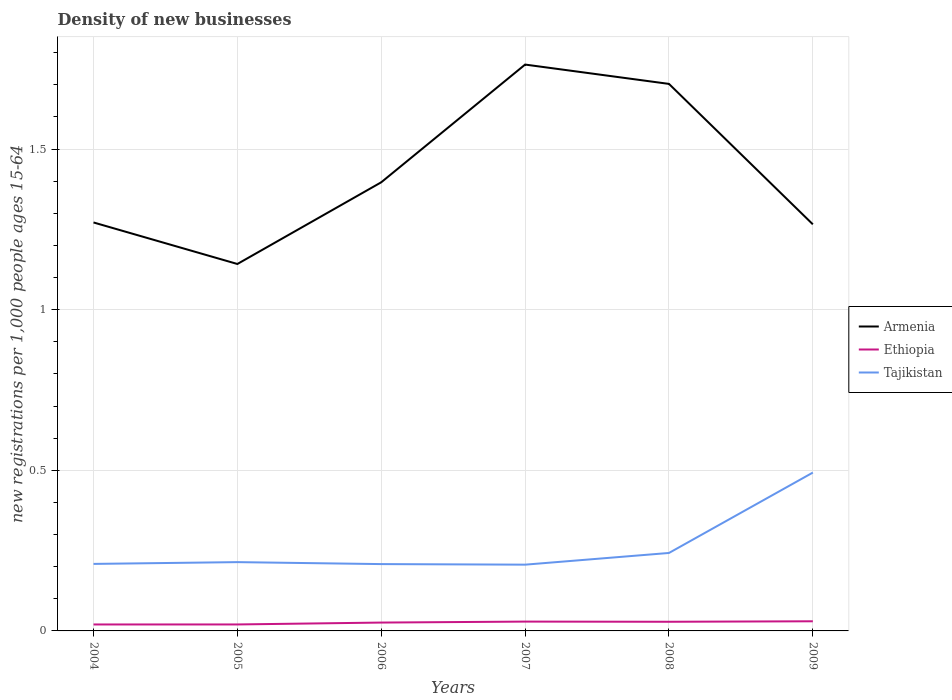How many different coloured lines are there?
Keep it short and to the point. 3. Across all years, what is the maximum number of new registrations in Armenia?
Offer a terse response. 1.14. In which year was the number of new registrations in Tajikistan maximum?
Make the answer very short. 2007. What is the total number of new registrations in Armenia in the graph?
Offer a very short reply. 0.13. What is the difference between the highest and the second highest number of new registrations in Tajikistan?
Keep it short and to the point. 0.29. What is the difference between the highest and the lowest number of new registrations in Ethiopia?
Your response must be concise. 4. How many lines are there?
Offer a terse response. 3. How many years are there in the graph?
Your answer should be compact. 6. Does the graph contain any zero values?
Provide a short and direct response. No. Where does the legend appear in the graph?
Give a very brief answer. Center right. How many legend labels are there?
Your response must be concise. 3. How are the legend labels stacked?
Give a very brief answer. Vertical. What is the title of the graph?
Give a very brief answer. Density of new businesses. What is the label or title of the Y-axis?
Your answer should be compact. New registrations per 1,0 people ages 15-64. What is the new registrations per 1,000 people ages 15-64 of Armenia in 2004?
Give a very brief answer. 1.27. What is the new registrations per 1,000 people ages 15-64 of Ethiopia in 2004?
Your answer should be very brief. 0.02. What is the new registrations per 1,000 people ages 15-64 of Tajikistan in 2004?
Offer a very short reply. 0.21. What is the new registrations per 1,000 people ages 15-64 of Armenia in 2005?
Provide a succinct answer. 1.14. What is the new registrations per 1,000 people ages 15-64 in Ethiopia in 2005?
Provide a short and direct response. 0.02. What is the new registrations per 1,000 people ages 15-64 in Tajikistan in 2005?
Offer a very short reply. 0.21. What is the new registrations per 1,000 people ages 15-64 in Armenia in 2006?
Your answer should be very brief. 1.4. What is the new registrations per 1,000 people ages 15-64 of Ethiopia in 2006?
Your answer should be compact. 0.03. What is the new registrations per 1,000 people ages 15-64 in Tajikistan in 2006?
Keep it short and to the point. 0.21. What is the new registrations per 1,000 people ages 15-64 in Armenia in 2007?
Make the answer very short. 1.76. What is the new registrations per 1,000 people ages 15-64 in Ethiopia in 2007?
Give a very brief answer. 0.03. What is the new registrations per 1,000 people ages 15-64 of Tajikistan in 2007?
Your response must be concise. 0.21. What is the new registrations per 1,000 people ages 15-64 in Armenia in 2008?
Keep it short and to the point. 1.7. What is the new registrations per 1,000 people ages 15-64 of Ethiopia in 2008?
Your answer should be very brief. 0.03. What is the new registrations per 1,000 people ages 15-64 in Tajikistan in 2008?
Ensure brevity in your answer.  0.24. What is the new registrations per 1,000 people ages 15-64 of Armenia in 2009?
Ensure brevity in your answer.  1.27. What is the new registrations per 1,000 people ages 15-64 in Tajikistan in 2009?
Provide a succinct answer. 0.49. Across all years, what is the maximum new registrations per 1,000 people ages 15-64 of Armenia?
Provide a short and direct response. 1.76. Across all years, what is the maximum new registrations per 1,000 people ages 15-64 of Ethiopia?
Keep it short and to the point. 0.03. Across all years, what is the maximum new registrations per 1,000 people ages 15-64 of Tajikistan?
Give a very brief answer. 0.49. Across all years, what is the minimum new registrations per 1,000 people ages 15-64 in Armenia?
Provide a succinct answer. 1.14. Across all years, what is the minimum new registrations per 1,000 people ages 15-64 of Ethiopia?
Ensure brevity in your answer.  0.02. Across all years, what is the minimum new registrations per 1,000 people ages 15-64 of Tajikistan?
Ensure brevity in your answer.  0.21. What is the total new registrations per 1,000 people ages 15-64 in Armenia in the graph?
Make the answer very short. 8.54. What is the total new registrations per 1,000 people ages 15-64 of Ethiopia in the graph?
Make the answer very short. 0.15. What is the total new registrations per 1,000 people ages 15-64 of Tajikistan in the graph?
Give a very brief answer. 1.57. What is the difference between the new registrations per 1,000 people ages 15-64 of Armenia in 2004 and that in 2005?
Your answer should be compact. 0.13. What is the difference between the new registrations per 1,000 people ages 15-64 of Ethiopia in 2004 and that in 2005?
Make the answer very short. -0. What is the difference between the new registrations per 1,000 people ages 15-64 of Tajikistan in 2004 and that in 2005?
Keep it short and to the point. -0.01. What is the difference between the new registrations per 1,000 people ages 15-64 in Armenia in 2004 and that in 2006?
Provide a short and direct response. -0.12. What is the difference between the new registrations per 1,000 people ages 15-64 of Ethiopia in 2004 and that in 2006?
Give a very brief answer. -0.01. What is the difference between the new registrations per 1,000 people ages 15-64 of Tajikistan in 2004 and that in 2006?
Make the answer very short. 0. What is the difference between the new registrations per 1,000 people ages 15-64 in Armenia in 2004 and that in 2007?
Ensure brevity in your answer.  -0.49. What is the difference between the new registrations per 1,000 people ages 15-64 in Ethiopia in 2004 and that in 2007?
Ensure brevity in your answer.  -0.01. What is the difference between the new registrations per 1,000 people ages 15-64 of Tajikistan in 2004 and that in 2007?
Make the answer very short. 0. What is the difference between the new registrations per 1,000 people ages 15-64 in Armenia in 2004 and that in 2008?
Your answer should be compact. -0.43. What is the difference between the new registrations per 1,000 people ages 15-64 in Ethiopia in 2004 and that in 2008?
Give a very brief answer. -0.01. What is the difference between the new registrations per 1,000 people ages 15-64 in Tajikistan in 2004 and that in 2008?
Your answer should be very brief. -0.03. What is the difference between the new registrations per 1,000 people ages 15-64 in Armenia in 2004 and that in 2009?
Provide a succinct answer. 0.01. What is the difference between the new registrations per 1,000 people ages 15-64 in Ethiopia in 2004 and that in 2009?
Make the answer very short. -0.01. What is the difference between the new registrations per 1,000 people ages 15-64 of Tajikistan in 2004 and that in 2009?
Offer a terse response. -0.28. What is the difference between the new registrations per 1,000 people ages 15-64 of Armenia in 2005 and that in 2006?
Make the answer very short. -0.25. What is the difference between the new registrations per 1,000 people ages 15-64 in Ethiopia in 2005 and that in 2006?
Offer a terse response. -0.01. What is the difference between the new registrations per 1,000 people ages 15-64 of Tajikistan in 2005 and that in 2006?
Offer a terse response. 0.01. What is the difference between the new registrations per 1,000 people ages 15-64 of Armenia in 2005 and that in 2007?
Provide a short and direct response. -0.62. What is the difference between the new registrations per 1,000 people ages 15-64 of Ethiopia in 2005 and that in 2007?
Your answer should be compact. -0.01. What is the difference between the new registrations per 1,000 people ages 15-64 in Tajikistan in 2005 and that in 2007?
Make the answer very short. 0.01. What is the difference between the new registrations per 1,000 people ages 15-64 in Armenia in 2005 and that in 2008?
Keep it short and to the point. -0.56. What is the difference between the new registrations per 1,000 people ages 15-64 of Ethiopia in 2005 and that in 2008?
Ensure brevity in your answer.  -0.01. What is the difference between the new registrations per 1,000 people ages 15-64 of Tajikistan in 2005 and that in 2008?
Give a very brief answer. -0.03. What is the difference between the new registrations per 1,000 people ages 15-64 in Armenia in 2005 and that in 2009?
Keep it short and to the point. -0.12. What is the difference between the new registrations per 1,000 people ages 15-64 of Ethiopia in 2005 and that in 2009?
Give a very brief answer. -0.01. What is the difference between the new registrations per 1,000 people ages 15-64 of Tajikistan in 2005 and that in 2009?
Give a very brief answer. -0.28. What is the difference between the new registrations per 1,000 people ages 15-64 in Armenia in 2006 and that in 2007?
Ensure brevity in your answer.  -0.37. What is the difference between the new registrations per 1,000 people ages 15-64 of Ethiopia in 2006 and that in 2007?
Your answer should be very brief. -0. What is the difference between the new registrations per 1,000 people ages 15-64 in Tajikistan in 2006 and that in 2007?
Make the answer very short. 0. What is the difference between the new registrations per 1,000 people ages 15-64 of Armenia in 2006 and that in 2008?
Provide a succinct answer. -0.31. What is the difference between the new registrations per 1,000 people ages 15-64 in Ethiopia in 2006 and that in 2008?
Ensure brevity in your answer.  -0. What is the difference between the new registrations per 1,000 people ages 15-64 of Tajikistan in 2006 and that in 2008?
Your answer should be very brief. -0.03. What is the difference between the new registrations per 1,000 people ages 15-64 in Armenia in 2006 and that in 2009?
Offer a terse response. 0.13. What is the difference between the new registrations per 1,000 people ages 15-64 in Ethiopia in 2006 and that in 2009?
Your answer should be compact. -0. What is the difference between the new registrations per 1,000 people ages 15-64 in Tajikistan in 2006 and that in 2009?
Ensure brevity in your answer.  -0.28. What is the difference between the new registrations per 1,000 people ages 15-64 of Armenia in 2007 and that in 2008?
Provide a succinct answer. 0.06. What is the difference between the new registrations per 1,000 people ages 15-64 of Ethiopia in 2007 and that in 2008?
Provide a succinct answer. 0. What is the difference between the new registrations per 1,000 people ages 15-64 in Tajikistan in 2007 and that in 2008?
Ensure brevity in your answer.  -0.04. What is the difference between the new registrations per 1,000 people ages 15-64 of Armenia in 2007 and that in 2009?
Keep it short and to the point. 0.5. What is the difference between the new registrations per 1,000 people ages 15-64 in Ethiopia in 2007 and that in 2009?
Keep it short and to the point. -0. What is the difference between the new registrations per 1,000 people ages 15-64 of Tajikistan in 2007 and that in 2009?
Make the answer very short. -0.29. What is the difference between the new registrations per 1,000 people ages 15-64 of Armenia in 2008 and that in 2009?
Offer a terse response. 0.44. What is the difference between the new registrations per 1,000 people ages 15-64 of Ethiopia in 2008 and that in 2009?
Offer a terse response. -0. What is the difference between the new registrations per 1,000 people ages 15-64 in Tajikistan in 2008 and that in 2009?
Give a very brief answer. -0.25. What is the difference between the new registrations per 1,000 people ages 15-64 in Armenia in 2004 and the new registrations per 1,000 people ages 15-64 in Ethiopia in 2005?
Make the answer very short. 1.25. What is the difference between the new registrations per 1,000 people ages 15-64 of Armenia in 2004 and the new registrations per 1,000 people ages 15-64 of Tajikistan in 2005?
Your answer should be very brief. 1.06. What is the difference between the new registrations per 1,000 people ages 15-64 in Ethiopia in 2004 and the new registrations per 1,000 people ages 15-64 in Tajikistan in 2005?
Offer a terse response. -0.19. What is the difference between the new registrations per 1,000 people ages 15-64 in Armenia in 2004 and the new registrations per 1,000 people ages 15-64 in Ethiopia in 2006?
Keep it short and to the point. 1.25. What is the difference between the new registrations per 1,000 people ages 15-64 of Armenia in 2004 and the new registrations per 1,000 people ages 15-64 of Tajikistan in 2006?
Your answer should be compact. 1.06. What is the difference between the new registrations per 1,000 people ages 15-64 in Ethiopia in 2004 and the new registrations per 1,000 people ages 15-64 in Tajikistan in 2006?
Offer a terse response. -0.19. What is the difference between the new registrations per 1,000 people ages 15-64 in Armenia in 2004 and the new registrations per 1,000 people ages 15-64 in Ethiopia in 2007?
Offer a very short reply. 1.24. What is the difference between the new registrations per 1,000 people ages 15-64 in Armenia in 2004 and the new registrations per 1,000 people ages 15-64 in Tajikistan in 2007?
Ensure brevity in your answer.  1.07. What is the difference between the new registrations per 1,000 people ages 15-64 in Ethiopia in 2004 and the new registrations per 1,000 people ages 15-64 in Tajikistan in 2007?
Your answer should be very brief. -0.19. What is the difference between the new registrations per 1,000 people ages 15-64 of Armenia in 2004 and the new registrations per 1,000 people ages 15-64 of Ethiopia in 2008?
Offer a terse response. 1.24. What is the difference between the new registrations per 1,000 people ages 15-64 of Armenia in 2004 and the new registrations per 1,000 people ages 15-64 of Tajikistan in 2008?
Ensure brevity in your answer.  1.03. What is the difference between the new registrations per 1,000 people ages 15-64 of Ethiopia in 2004 and the new registrations per 1,000 people ages 15-64 of Tajikistan in 2008?
Provide a short and direct response. -0.22. What is the difference between the new registrations per 1,000 people ages 15-64 in Armenia in 2004 and the new registrations per 1,000 people ages 15-64 in Ethiopia in 2009?
Make the answer very short. 1.24. What is the difference between the new registrations per 1,000 people ages 15-64 of Armenia in 2004 and the new registrations per 1,000 people ages 15-64 of Tajikistan in 2009?
Your response must be concise. 0.78. What is the difference between the new registrations per 1,000 people ages 15-64 in Ethiopia in 2004 and the new registrations per 1,000 people ages 15-64 in Tajikistan in 2009?
Provide a succinct answer. -0.47. What is the difference between the new registrations per 1,000 people ages 15-64 in Armenia in 2005 and the new registrations per 1,000 people ages 15-64 in Ethiopia in 2006?
Give a very brief answer. 1.12. What is the difference between the new registrations per 1,000 people ages 15-64 in Armenia in 2005 and the new registrations per 1,000 people ages 15-64 in Tajikistan in 2006?
Provide a succinct answer. 0.93. What is the difference between the new registrations per 1,000 people ages 15-64 in Ethiopia in 2005 and the new registrations per 1,000 people ages 15-64 in Tajikistan in 2006?
Keep it short and to the point. -0.19. What is the difference between the new registrations per 1,000 people ages 15-64 of Armenia in 2005 and the new registrations per 1,000 people ages 15-64 of Ethiopia in 2007?
Your answer should be compact. 1.11. What is the difference between the new registrations per 1,000 people ages 15-64 in Armenia in 2005 and the new registrations per 1,000 people ages 15-64 in Tajikistan in 2007?
Provide a succinct answer. 0.94. What is the difference between the new registrations per 1,000 people ages 15-64 in Ethiopia in 2005 and the new registrations per 1,000 people ages 15-64 in Tajikistan in 2007?
Provide a succinct answer. -0.19. What is the difference between the new registrations per 1,000 people ages 15-64 of Armenia in 2005 and the new registrations per 1,000 people ages 15-64 of Ethiopia in 2008?
Provide a short and direct response. 1.11. What is the difference between the new registrations per 1,000 people ages 15-64 of Armenia in 2005 and the new registrations per 1,000 people ages 15-64 of Tajikistan in 2008?
Provide a short and direct response. 0.9. What is the difference between the new registrations per 1,000 people ages 15-64 in Ethiopia in 2005 and the new registrations per 1,000 people ages 15-64 in Tajikistan in 2008?
Your answer should be very brief. -0.22. What is the difference between the new registrations per 1,000 people ages 15-64 in Armenia in 2005 and the new registrations per 1,000 people ages 15-64 in Ethiopia in 2009?
Offer a terse response. 1.11. What is the difference between the new registrations per 1,000 people ages 15-64 in Armenia in 2005 and the new registrations per 1,000 people ages 15-64 in Tajikistan in 2009?
Give a very brief answer. 0.65. What is the difference between the new registrations per 1,000 people ages 15-64 of Ethiopia in 2005 and the new registrations per 1,000 people ages 15-64 of Tajikistan in 2009?
Give a very brief answer. -0.47. What is the difference between the new registrations per 1,000 people ages 15-64 in Armenia in 2006 and the new registrations per 1,000 people ages 15-64 in Ethiopia in 2007?
Offer a very short reply. 1.37. What is the difference between the new registrations per 1,000 people ages 15-64 of Armenia in 2006 and the new registrations per 1,000 people ages 15-64 of Tajikistan in 2007?
Ensure brevity in your answer.  1.19. What is the difference between the new registrations per 1,000 people ages 15-64 in Ethiopia in 2006 and the new registrations per 1,000 people ages 15-64 in Tajikistan in 2007?
Provide a short and direct response. -0.18. What is the difference between the new registrations per 1,000 people ages 15-64 in Armenia in 2006 and the new registrations per 1,000 people ages 15-64 in Ethiopia in 2008?
Your answer should be compact. 1.37. What is the difference between the new registrations per 1,000 people ages 15-64 in Armenia in 2006 and the new registrations per 1,000 people ages 15-64 in Tajikistan in 2008?
Give a very brief answer. 1.15. What is the difference between the new registrations per 1,000 people ages 15-64 in Ethiopia in 2006 and the new registrations per 1,000 people ages 15-64 in Tajikistan in 2008?
Offer a very short reply. -0.22. What is the difference between the new registrations per 1,000 people ages 15-64 in Armenia in 2006 and the new registrations per 1,000 people ages 15-64 in Ethiopia in 2009?
Ensure brevity in your answer.  1.37. What is the difference between the new registrations per 1,000 people ages 15-64 of Armenia in 2006 and the new registrations per 1,000 people ages 15-64 of Tajikistan in 2009?
Offer a very short reply. 0.9. What is the difference between the new registrations per 1,000 people ages 15-64 of Ethiopia in 2006 and the new registrations per 1,000 people ages 15-64 of Tajikistan in 2009?
Your answer should be very brief. -0.47. What is the difference between the new registrations per 1,000 people ages 15-64 in Armenia in 2007 and the new registrations per 1,000 people ages 15-64 in Ethiopia in 2008?
Provide a short and direct response. 1.73. What is the difference between the new registrations per 1,000 people ages 15-64 in Armenia in 2007 and the new registrations per 1,000 people ages 15-64 in Tajikistan in 2008?
Provide a short and direct response. 1.52. What is the difference between the new registrations per 1,000 people ages 15-64 of Ethiopia in 2007 and the new registrations per 1,000 people ages 15-64 of Tajikistan in 2008?
Your answer should be compact. -0.21. What is the difference between the new registrations per 1,000 people ages 15-64 of Armenia in 2007 and the new registrations per 1,000 people ages 15-64 of Ethiopia in 2009?
Offer a terse response. 1.73. What is the difference between the new registrations per 1,000 people ages 15-64 of Armenia in 2007 and the new registrations per 1,000 people ages 15-64 of Tajikistan in 2009?
Provide a short and direct response. 1.27. What is the difference between the new registrations per 1,000 people ages 15-64 of Ethiopia in 2007 and the new registrations per 1,000 people ages 15-64 of Tajikistan in 2009?
Ensure brevity in your answer.  -0.46. What is the difference between the new registrations per 1,000 people ages 15-64 in Armenia in 2008 and the new registrations per 1,000 people ages 15-64 in Ethiopia in 2009?
Your answer should be very brief. 1.67. What is the difference between the new registrations per 1,000 people ages 15-64 in Armenia in 2008 and the new registrations per 1,000 people ages 15-64 in Tajikistan in 2009?
Provide a short and direct response. 1.21. What is the difference between the new registrations per 1,000 people ages 15-64 in Ethiopia in 2008 and the new registrations per 1,000 people ages 15-64 in Tajikistan in 2009?
Give a very brief answer. -0.46. What is the average new registrations per 1,000 people ages 15-64 in Armenia per year?
Offer a very short reply. 1.42. What is the average new registrations per 1,000 people ages 15-64 of Ethiopia per year?
Your response must be concise. 0.03. What is the average new registrations per 1,000 people ages 15-64 of Tajikistan per year?
Make the answer very short. 0.26. In the year 2004, what is the difference between the new registrations per 1,000 people ages 15-64 in Armenia and new registrations per 1,000 people ages 15-64 in Ethiopia?
Ensure brevity in your answer.  1.25. In the year 2004, what is the difference between the new registrations per 1,000 people ages 15-64 in Armenia and new registrations per 1,000 people ages 15-64 in Tajikistan?
Provide a succinct answer. 1.06. In the year 2004, what is the difference between the new registrations per 1,000 people ages 15-64 in Ethiopia and new registrations per 1,000 people ages 15-64 in Tajikistan?
Your response must be concise. -0.19. In the year 2005, what is the difference between the new registrations per 1,000 people ages 15-64 in Armenia and new registrations per 1,000 people ages 15-64 in Ethiopia?
Your answer should be compact. 1.12. In the year 2005, what is the difference between the new registrations per 1,000 people ages 15-64 in Armenia and new registrations per 1,000 people ages 15-64 in Tajikistan?
Offer a very short reply. 0.93. In the year 2005, what is the difference between the new registrations per 1,000 people ages 15-64 in Ethiopia and new registrations per 1,000 people ages 15-64 in Tajikistan?
Offer a very short reply. -0.19. In the year 2006, what is the difference between the new registrations per 1,000 people ages 15-64 in Armenia and new registrations per 1,000 people ages 15-64 in Ethiopia?
Your answer should be compact. 1.37. In the year 2006, what is the difference between the new registrations per 1,000 people ages 15-64 in Armenia and new registrations per 1,000 people ages 15-64 in Tajikistan?
Keep it short and to the point. 1.19. In the year 2006, what is the difference between the new registrations per 1,000 people ages 15-64 in Ethiopia and new registrations per 1,000 people ages 15-64 in Tajikistan?
Your answer should be compact. -0.18. In the year 2007, what is the difference between the new registrations per 1,000 people ages 15-64 in Armenia and new registrations per 1,000 people ages 15-64 in Ethiopia?
Keep it short and to the point. 1.73. In the year 2007, what is the difference between the new registrations per 1,000 people ages 15-64 in Armenia and new registrations per 1,000 people ages 15-64 in Tajikistan?
Offer a terse response. 1.56. In the year 2007, what is the difference between the new registrations per 1,000 people ages 15-64 of Ethiopia and new registrations per 1,000 people ages 15-64 of Tajikistan?
Provide a succinct answer. -0.18. In the year 2008, what is the difference between the new registrations per 1,000 people ages 15-64 in Armenia and new registrations per 1,000 people ages 15-64 in Ethiopia?
Ensure brevity in your answer.  1.67. In the year 2008, what is the difference between the new registrations per 1,000 people ages 15-64 in Armenia and new registrations per 1,000 people ages 15-64 in Tajikistan?
Give a very brief answer. 1.46. In the year 2008, what is the difference between the new registrations per 1,000 people ages 15-64 of Ethiopia and new registrations per 1,000 people ages 15-64 of Tajikistan?
Provide a short and direct response. -0.21. In the year 2009, what is the difference between the new registrations per 1,000 people ages 15-64 in Armenia and new registrations per 1,000 people ages 15-64 in Ethiopia?
Ensure brevity in your answer.  1.24. In the year 2009, what is the difference between the new registrations per 1,000 people ages 15-64 of Armenia and new registrations per 1,000 people ages 15-64 of Tajikistan?
Ensure brevity in your answer.  0.77. In the year 2009, what is the difference between the new registrations per 1,000 people ages 15-64 of Ethiopia and new registrations per 1,000 people ages 15-64 of Tajikistan?
Ensure brevity in your answer.  -0.46. What is the ratio of the new registrations per 1,000 people ages 15-64 in Armenia in 2004 to that in 2005?
Give a very brief answer. 1.11. What is the ratio of the new registrations per 1,000 people ages 15-64 in Ethiopia in 2004 to that in 2005?
Your answer should be very brief. 1. What is the ratio of the new registrations per 1,000 people ages 15-64 in Tajikistan in 2004 to that in 2005?
Keep it short and to the point. 0.97. What is the ratio of the new registrations per 1,000 people ages 15-64 in Armenia in 2004 to that in 2006?
Give a very brief answer. 0.91. What is the ratio of the new registrations per 1,000 people ages 15-64 of Ethiopia in 2004 to that in 2006?
Make the answer very short. 0.77. What is the ratio of the new registrations per 1,000 people ages 15-64 of Armenia in 2004 to that in 2007?
Offer a terse response. 0.72. What is the ratio of the new registrations per 1,000 people ages 15-64 in Ethiopia in 2004 to that in 2007?
Your answer should be very brief. 0.69. What is the ratio of the new registrations per 1,000 people ages 15-64 of Tajikistan in 2004 to that in 2007?
Your answer should be compact. 1.01. What is the ratio of the new registrations per 1,000 people ages 15-64 in Armenia in 2004 to that in 2008?
Your response must be concise. 0.75. What is the ratio of the new registrations per 1,000 people ages 15-64 in Ethiopia in 2004 to that in 2008?
Your response must be concise. 0.71. What is the ratio of the new registrations per 1,000 people ages 15-64 in Tajikistan in 2004 to that in 2008?
Keep it short and to the point. 0.86. What is the ratio of the new registrations per 1,000 people ages 15-64 in Ethiopia in 2004 to that in 2009?
Ensure brevity in your answer.  0.67. What is the ratio of the new registrations per 1,000 people ages 15-64 of Tajikistan in 2004 to that in 2009?
Provide a short and direct response. 0.42. What is the ratio of the new registrations per 1,000 people ages 15-64 in Armenia in 2005 to that in 2006?
Your answer should be very brief. 0.82. What is the ratio of the new registrations per 1,000 people ages 15-64 in Ethiopia in 2005 to that in 2006?
Provide a succinct answer. 0.77. What is the ratio of the new registrations per 1,000 people ages 15-64 of Tajikistan in 2005 to that in 2006?
Ensure brevity in your answer.  1.03. What is the ratio of the new registrations per 1,000 people ages 15-64 of Armenia in 2005 to that in 2007?
Your answer should be very brief. 0.65. What is the ratio of the new registrations per 1,000 people ages 15-64 of Ethiopia in 2005 to that in 2007?
Give a very brief answer. 0.69. What is the ratio of the new registrations per 1,000 people ages 15-64 in Tajikistan in 2005 to that in 2007?
Your response must be concise. 1.04. What is the ratio of the new registrations per 1,000 people ages 15-64 in Armenia in 2005 to that in 2008?
Your answer should be very brief. 0.67. What is the ratio of the new registrations per 1,000 people ages 15-64 of Ethiopia in 2005 to that in 2008?
Your response must be concise. 0.71. What is the ratio of the new registrations per 1,000 people ages 15-64 of Tajikistan in 2005 to that in 2008?
Offer a very short reply. 0.88. What is the ratio of the new registrations per 1,000 people ages 15-64 of Armenia in 2005 to that in 2009?
Your answer should be compact. 0.9. What is the ratio of the new registrations per 1,000 people ages 15-64 in Ethiopia in 2005 to that in 2009?
Your answer should be very brief. 0.67. What is the ratio of the new registrations per 1,000 people ages 15-64 in Tajikistan in 2005 to that in 2009?
Ensure brevity in your answer.  0.43. What is the ratio of the new registrations per 1,000 people ages 15-64 of Armenia in 2006 to that in 2007?
Make the answer very short. 0.79. What is the ratio of the new registrations per 1,000 people ages 15-64 of Ethiopia in 2006 to that in 2007?
Provide a short and direct response. 0.9. What is the ratio of the new registrations per 1,000 people ages 15-64 of Tajikistan in 2006 to that in 2007?
Give a very brief answer. 1.01. What is the ratio of the new registrations per 1,000 people ages 15-64 in Armenia in 2006 to that in 2008?
Keep it short and to the point. 0.82. What is the ratio of the new registrations per 1,000 people ages 15-64 of Ethiopia in 2006 to that in 2008?
Your answer should be very brief. 0.91. What is the ratio of the new registrations per 1,000 people ages 15-64 in Tajikistan in 2006 to that in 2008?
Offer a very short reply. 0.86. What is the ratio of the new registrations per 1,000 people ages 15-64 of Armenia in 2006 to that in 2009?
Make the answer very short. 1.1. What is the ratio of the new registrations per 1,000 people ages 15-64 of Ethiopia in 2006 to that in 2009?
Provide a short and direct response. 0.87. What is the ratio of the new registrations per 1,000 people ages 15-64 in Tajikistan in 2006 to that in 2009?
Provide a succinct answer. 0.42. What is the ratio of the new registrations per 1,000 people ages 15-64 of Armenia in 2007 to that in 2008?
Give a very brief answer. 1.04. What is the ratio of the new registrations per 1,000 people ages 15-64 in Ethiopia in 2007 to that in 2008?
Make the answer very short. 1.02. What is the ratio of the new registrations per 1,000 people ages 15-64 of Tajikistan in 2007 to that in 2008?
Ensure brevity in your answer.  0.85. What is the ratio of the new registrations per 1,000 people ages 15-64 of Armenia in 2007 to that in 2009?
Offer a terse response. 1.39. What is the ratio of the new registrations per 1,000 people ages 15-64 in Ethiopia in 2007 to that in 2009?
Give a very brief answer. 0.97. What is the ratio of the new registrations per 1,000 people ages 15-64 in Tajikistan in 2007 to that in 2009?
Offer a very short reply. 0.42. What is the ratio of the new registrations per 1,000 people ages 15-64 of Armenia in 2008 to that in 2009?
Offer a terse response. 1.35. What is the ratio of the new registrations per 1,000 people ages 15-64 of Ethiopia in 2008 to that in 2009?
Your answer should be very brief. 0.95. What is the ratio of the new registrations per 1,000 people ages 15-64 of Tajikistan in 2008 to that in 2009?
Your response must be concise. 0.49. What is the difference between the highest and the second highest new registrations per 1,000 people ages 15-64 of Armenia?
Offer a terse response. 0.06. What is the difference between the highest and the second highest new registrations per 1,000 people ages 15-64 of Tajikistan?
Your answer should be compact. 0.25. What is the difference between the highest and the lowest new registrations per 1,000 people ages 15-64 in Armenia?
Your answer should be very brief. 0.62. What is the difference between the highest and the lowest new registrations per 1,000 people ages 15-64 in Ethiopia?
Provide a short and direct response. 0.01. What is the difference between the highest and the lowest new registrations per 1,000 people ages 15-64 of Tajikistan?
Your response must be concise. 0.29. 